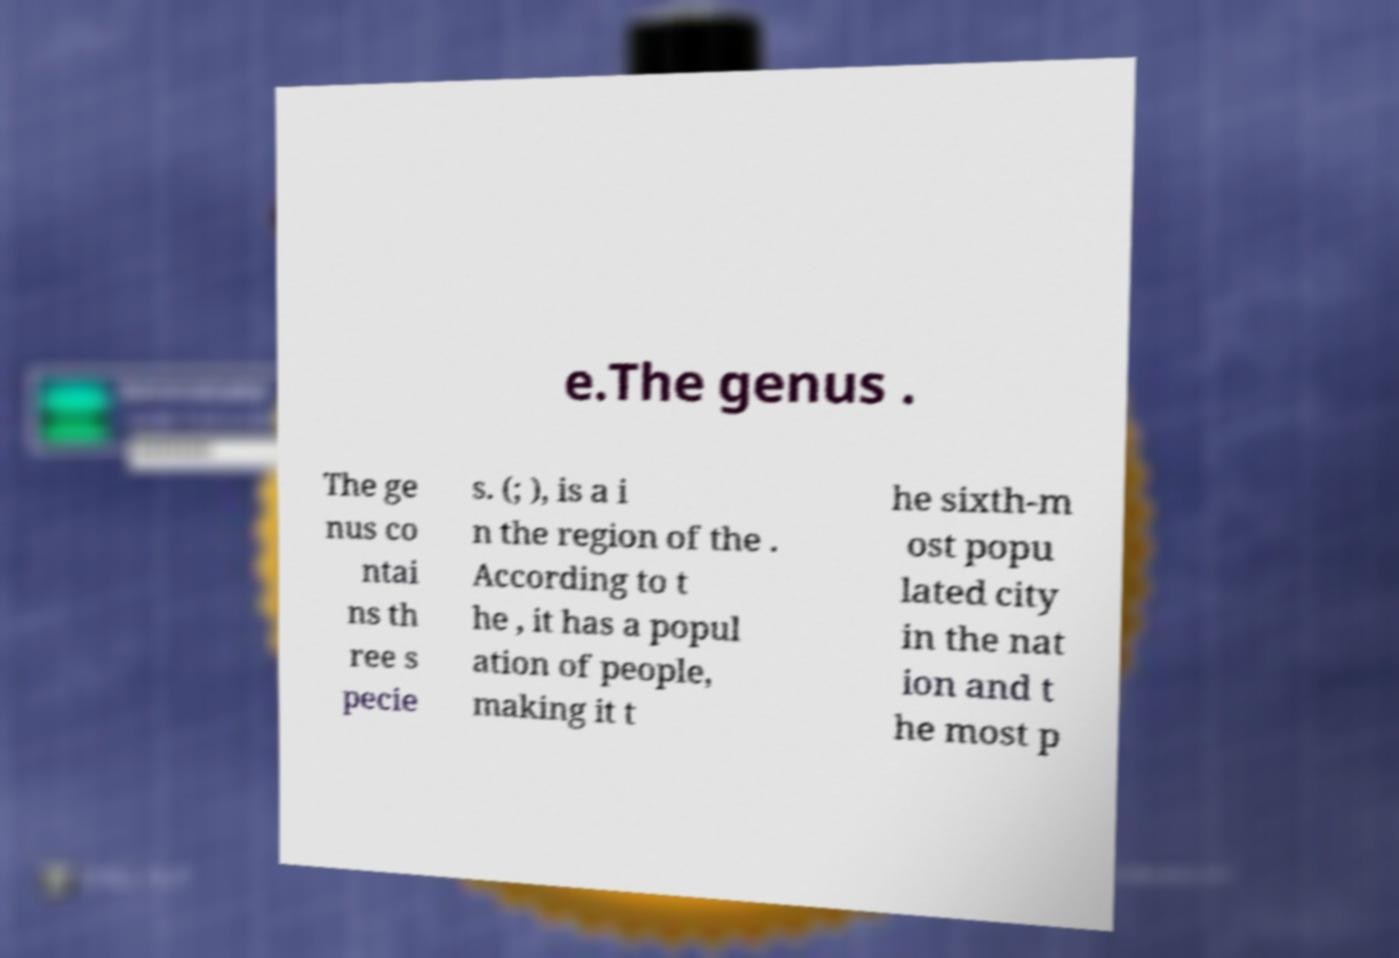Could you extract and type out the text from this image? e.The genus . The ge nus co ntai ns th ree s pecie s. (; ), is a i n the region of the . According to t he , it has a popul ation of people, making it t he sixth-m ost popu lated city in the nat ion and t he most p 